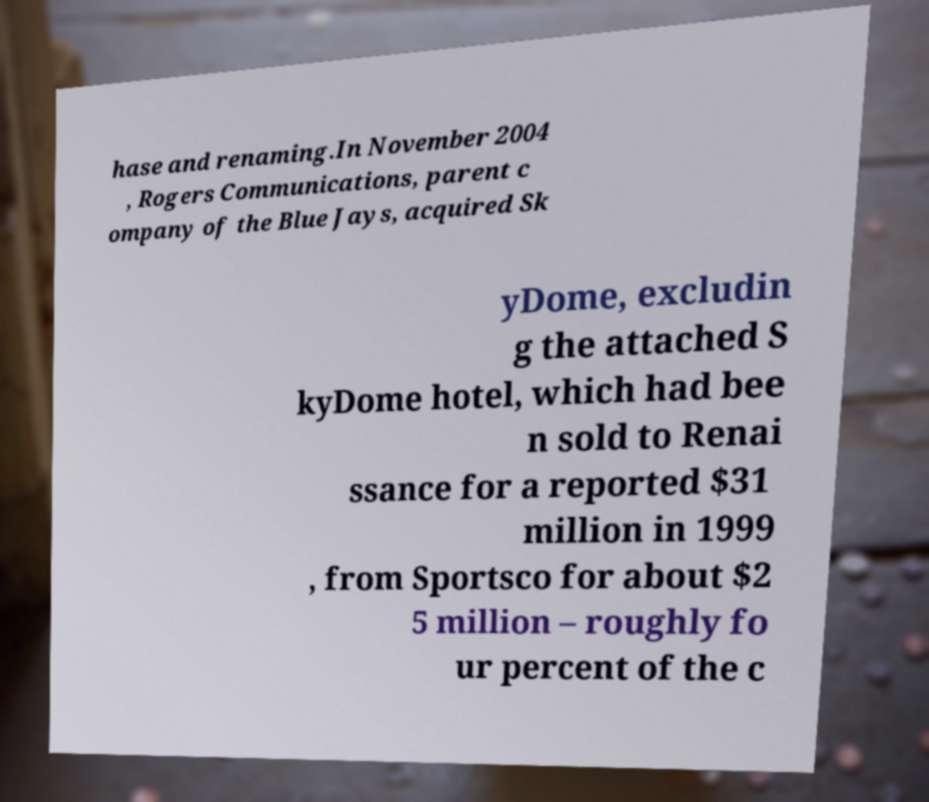I need the written content from this picture converted into text. Can you do that? hase and renaming.In November 2004 , Rogers Communications, parent c ompany of the Blue Jays, acquired Sk yDome, excludin g the attached S kyDome hotel, which had bee n sold to Renai ssance for a reported $31 million in 1999 , from Sportsco for about $2 5 million – roughly fo ur percent of the c 